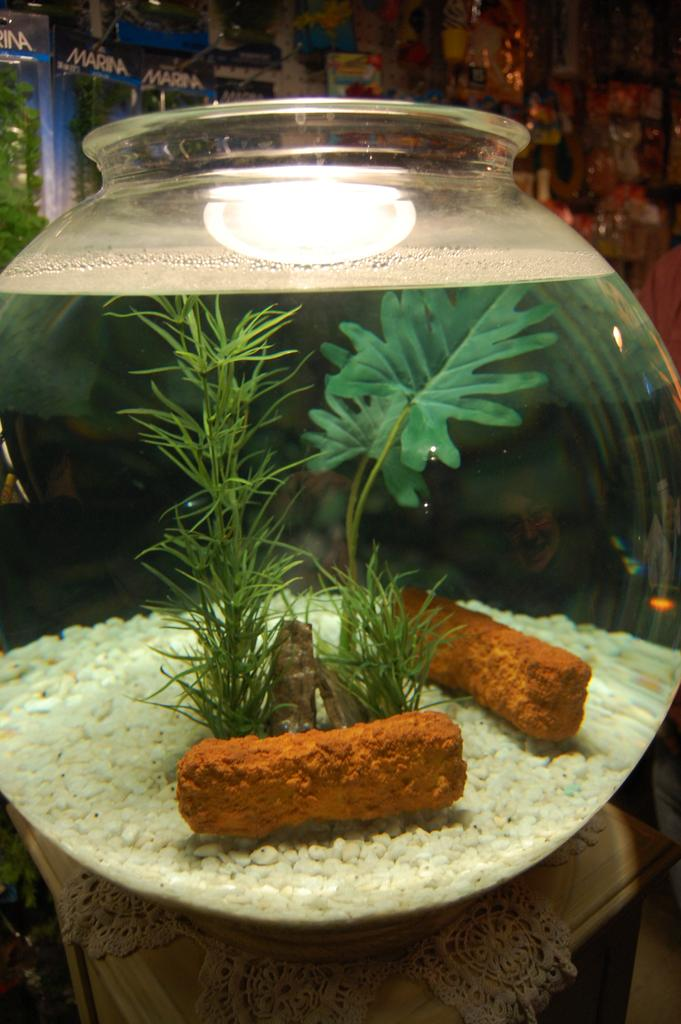What is on the table in the image? There is a glass bowl on the table in the image. What is inside the glass bowl? The bowl contains water, grass, leaves, and crystals. Are there any other items in the bowl? Yes, there are other unspecified items in the bowl. What can be seen behind the bowl? There are banners behind the bowl. Can you tell me how many birds are perched on the banners in the image? There are no birds present in the image; only the bowl, its contents, and the banners can be seen. 